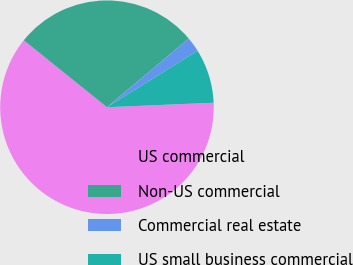<chart> <loc_0><loc_0><loc_500><loc_500><pie_chart><fcel>US commercial<fcel>Non-US commercial<fcel>Commercial real estate<fcel>US small business commercial<nl><fcel>61.45%<fcel>28.09%<fcel>2.27%<fcel>8.19%<nl></chart> 